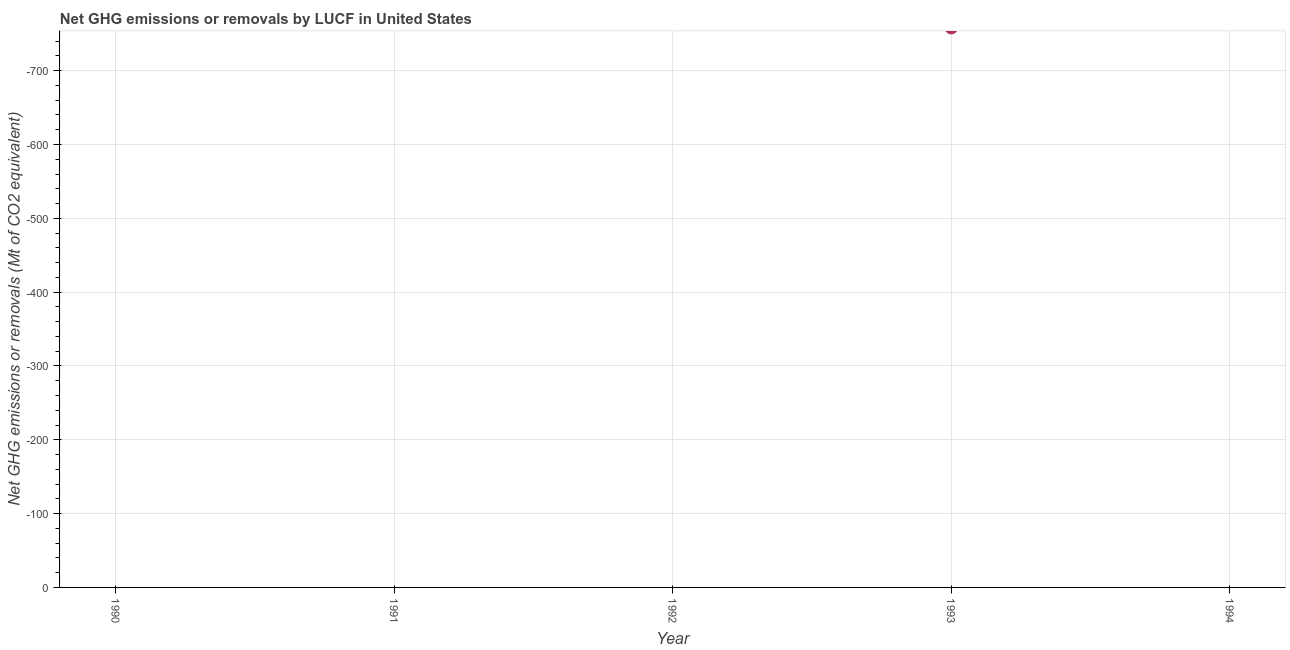What is the ghg net emissions or removals in 1992?
Offer a terse response. 0. What is the median ghg net emissions or removals?
Provide a short and direct response. 0. In how many years, is the ghg net emissions or removals greater than -740 Mt?
Your answer should be compact. 0. Does the ghg net emissions or removals monotonically increase over the years?
Your answer should be very brief. No. Does the graph contain grids?
Keep it short and to the point. Yes. What is the title of the graph?
Your answer should be compact. Net GHG emissions or removals by LUCF in United States. What is the label or title of the X-axis?
Keep it short and to the point. Year. What is the label or title of the Y-axis?
Your answer should be very brief. Net GHG emissions or removals (Mt of CO2 equivalent). What is the Net GHG emissions or removals (Mt of CO2 equivalent) in 1992?
Your response must be concise. 0. 